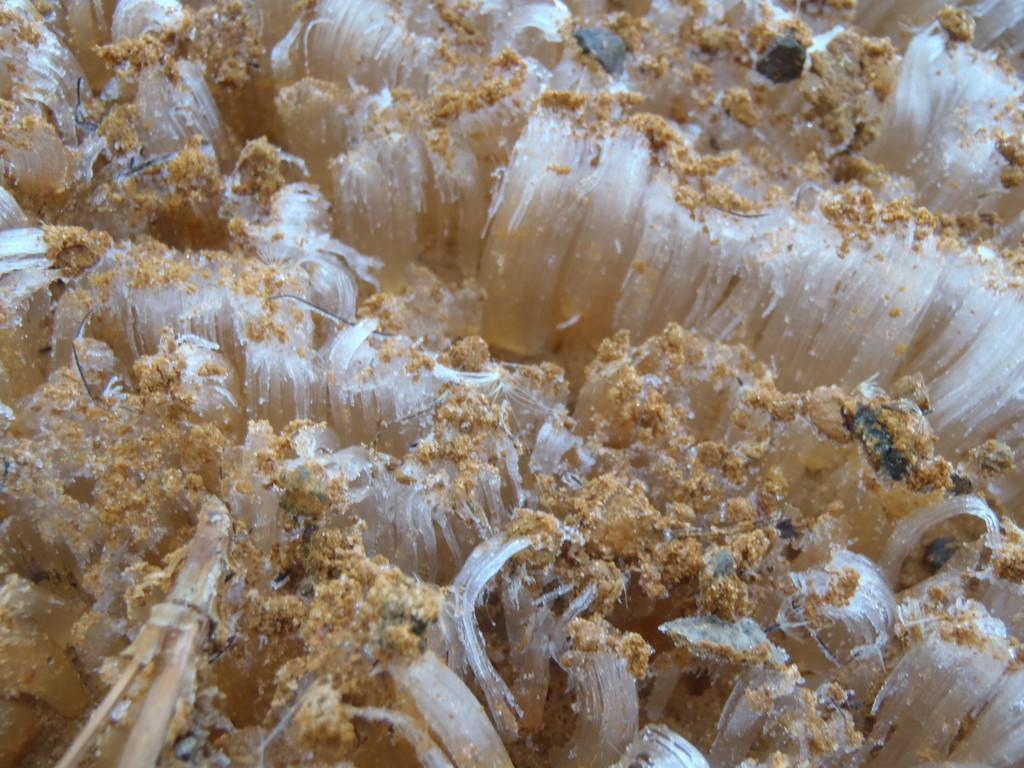What type of natural formation can be seen in the image? There are corals in the image. Can you describe the appearance of the corals? The corals have a unique and colorful structure in the image. What environment might these corals be found in? Corals are typically found in underwater environments, such as oceans and seas. What type of vase is displayed on the table in the image? There is no vase present in the image; it features corals. How many men are visible in the image? There are no men visible in the image; it features corals. 